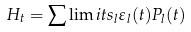<formula> <loc_0><loc_0><loc_500><loc_500>H _ { t } = \sum \lim i t s _ { l } \varepsilon _ { l } ( t ) P _ { l } ( t )</formula> 